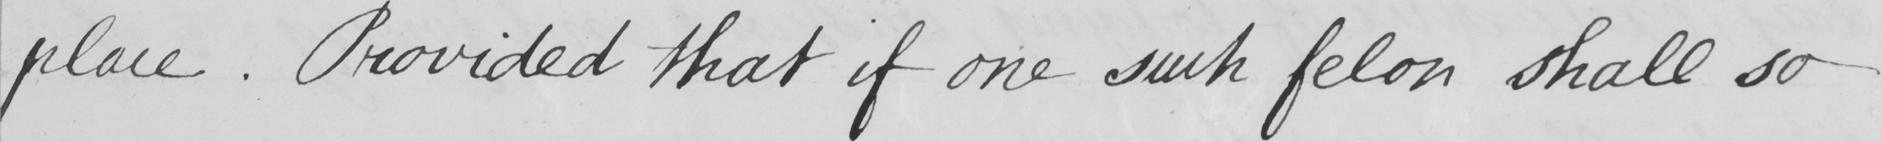What text is written in this handwritten line? place . Provided that if one such felon shall so 